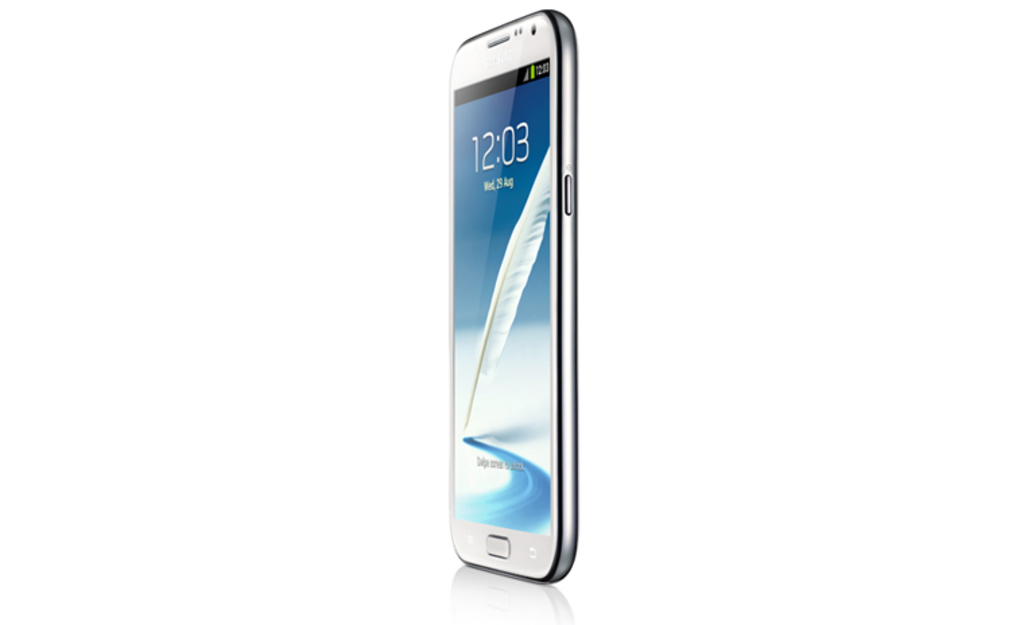Describe the aesthetic design of the phone shown in the image. The phone sports a sleek and modern design with a metallic frame and a smooth, white glass back, suggesting a focus on elegance and contemporary style. What might be the user experience advantages of such a design? The ergonomic curve and slim profile help in better hand fit and ease of use, while the high-quality display provides an immersive viewing experience for media consumption and interaction. 